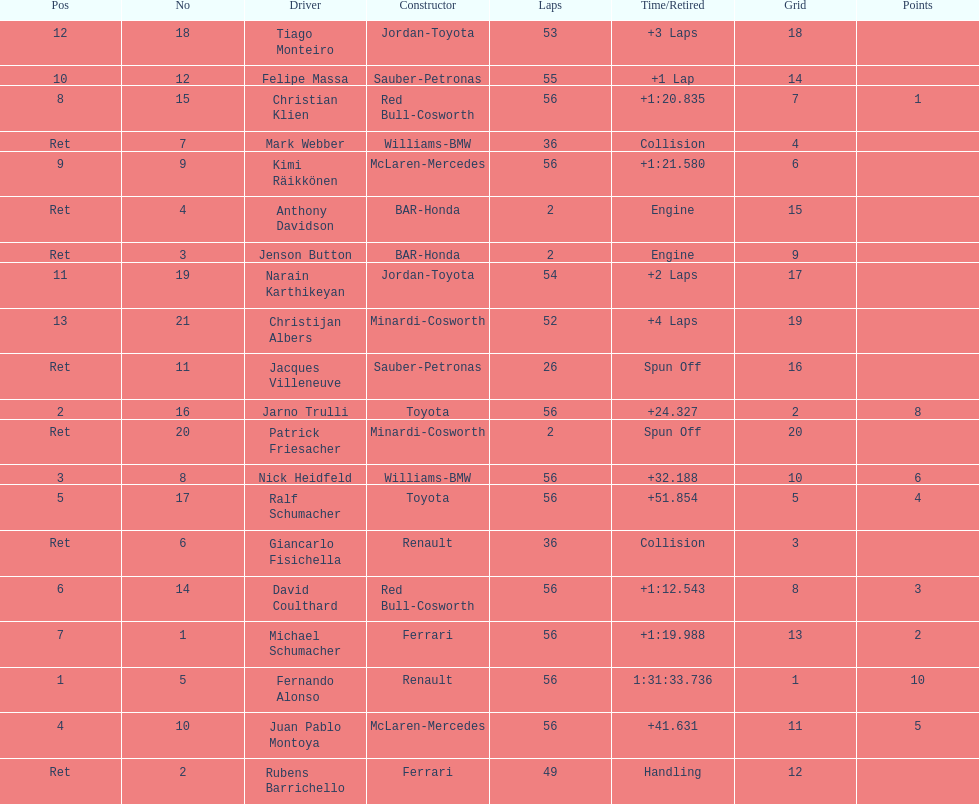Who was the last driver from the uk to actually finish the 56 laps? David Coulthard. 